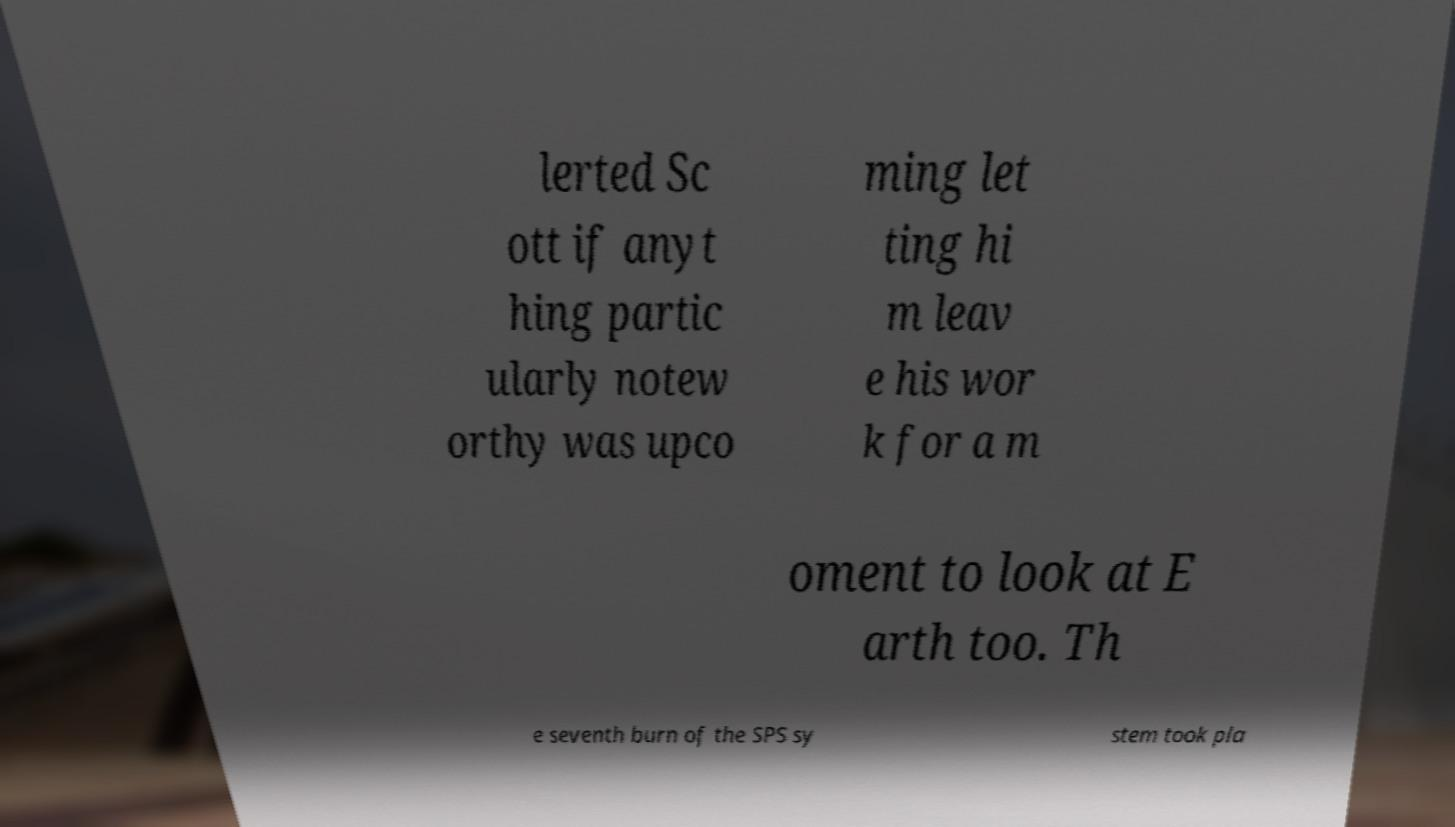Can you accurately transcribe the text from the provided image for me? lerted Sc ott if anyt hing partic ularly notew orthy was upco ming let ting hi m leav e his wor k for a m oment to look at E arth too. Th e seventh burn of the SPS sy stem took pla 